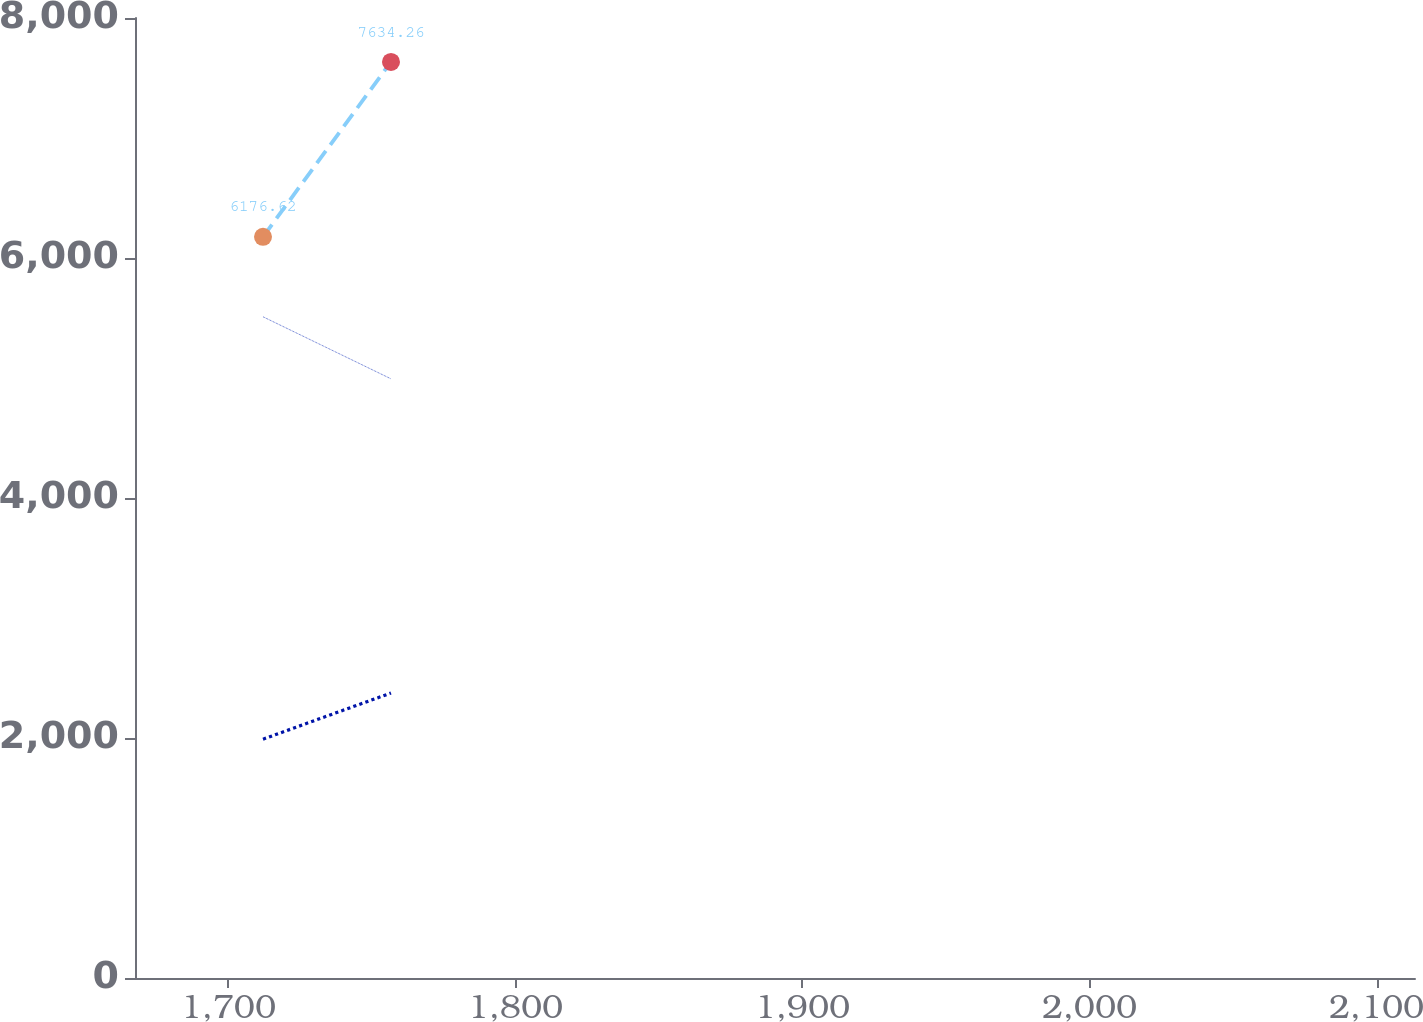Convert chart. <chart><loc_0><loc_0><loc_500><loc_500><line_chart><ecel><fcel>U.S.<fcel>Foreign (a)<fcel>Consolidated<nl><fcel>1712.05<fcel>5510.3<fcel>1990.48<fcel>6176.62<nl><fcel>1756.64<fcel>4993.09<fcel>2374.82<fcel>7634.26<nl><fcel>2158<fcel>4935.62<fcel>2528.77<fcel>7095.99<nl></chart> 